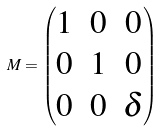<formula> <loc_0><loc_0><loc_500><loc_500>M = \begin{pmatrix} 1 & 0 & 0 \\ 0 & 1 & 0 \\ 0 & 0 & \delta \end{pmatrix}</formula> 